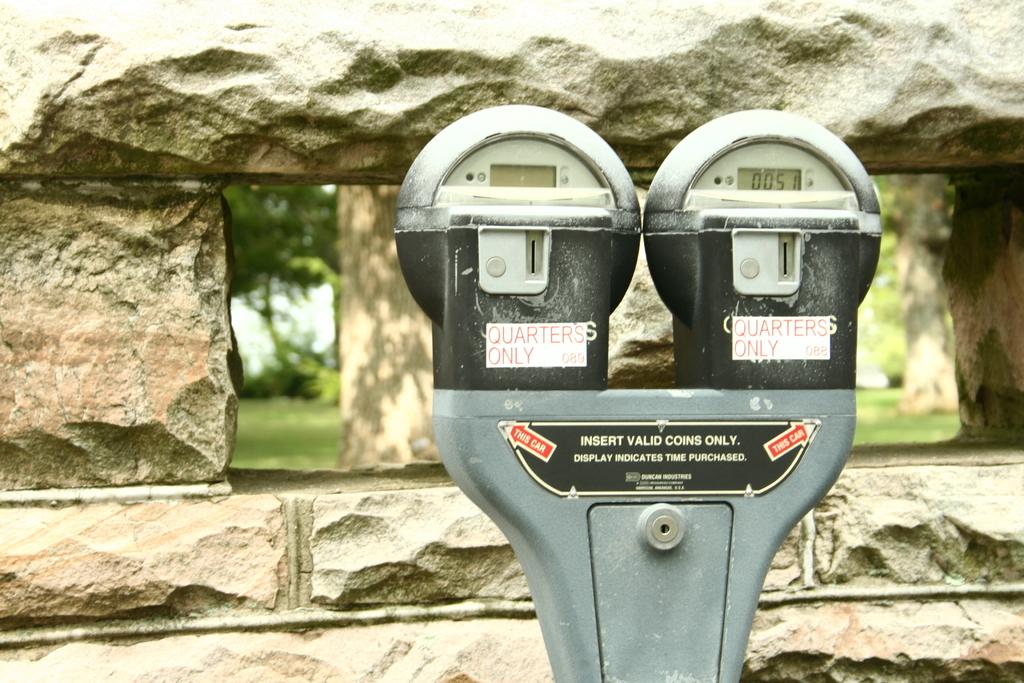How much time is left on the meter on the right?
Provide a short and direct response. 00:51. What type of coins do the meters take?
Make the answer very short. Quarters. 